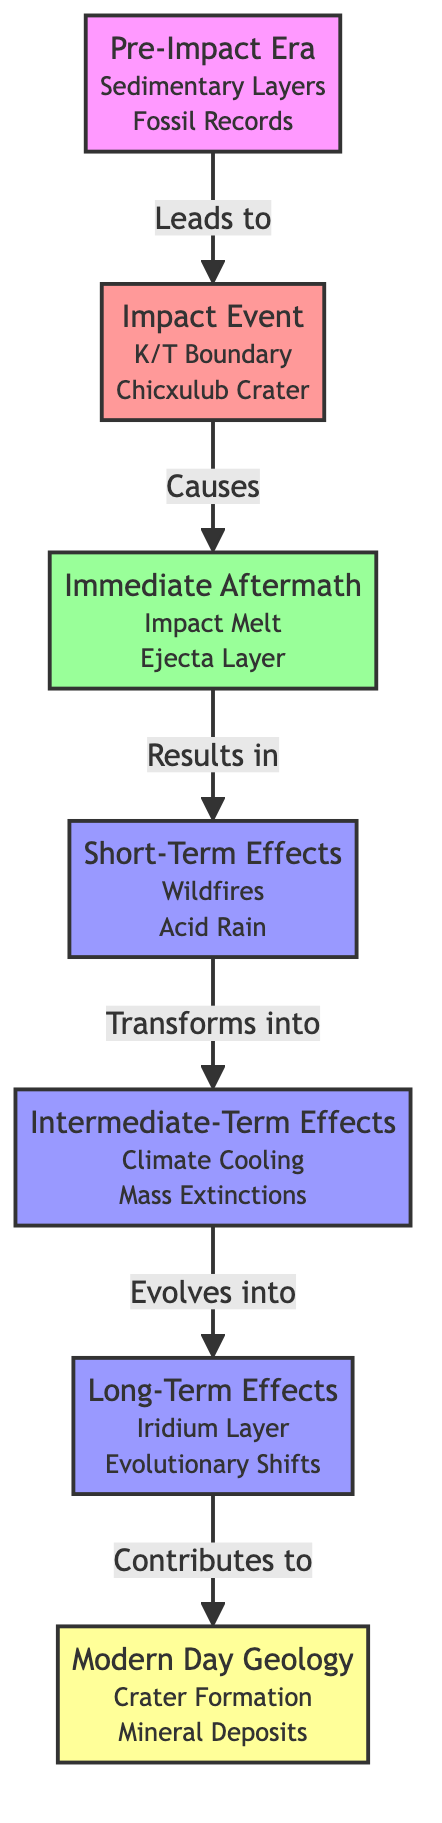What is the first stage of the geological timeline? The first stage is identified as "Pre-Impact Era" in the diagram, indicating the period before the impact event.
Answer: Pre-Impact Era What does the impact event cause? According to the diagram, the impact event leads to the "Immediate Aftermath," as indicated by the arrow connecting them.
Answer: Immediate Aftermath How many effects are listed in the diagram? The diagram lists four effects: "Short-Term Effects," "Intermediate-Term Effects," "Long-Term Effects," and "Modern Day Geology." This can be counted directly from the nodes.
Answer: 4 What is found in the "Long-Term Effects" stage? The "Iridium Layer" and "Evolutionary Shifts" are both part of the "Long-Term Effects" stage, as specified in the diagram.
Answer: Iridium Layer, Evolutionary Shifts Which stage directly follows the "Impact Event"? The diagram shows that the stage immediately following the "Impact Event" is the "Immediate Aftermath," clearly indicated by the directional arrow.
Answer: Immediate Aftermath What leads to climate cooling as per the timeline? Climate cooling is a consequence mentioned in the "Intermediate-Term Effects" and is caused by the "Short-Term Effects," which highlights the transformation from one to the other in the diagram.
Answer: Short-Term Effects What is the relationship between "Immediate Aftermath" and "Wildfires"? The "Immediate Aftermath" leads to "Short-Term Effects," which includes "Wildfires," establishing a direct cause-and-effect relationship between these stages in the timeline.
Answer: Causes What kind of deposits are mentioned in the modern stage? The diagram states that the "Modern Day Geology" stage includes "Mineral Deposits," which is the information presented in that specific node.
Answer: Mineral Deposits Which period experiences mass extinctions? The "Intermediate-Term Effects" stage includes "Mass Extinctions," directly indicating when this event occurs in the timeline.
Answer: Intermediate-Term Effects 